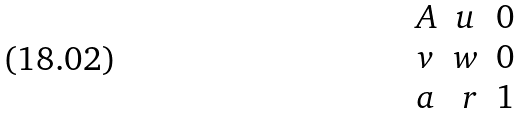Convert formula to latex. <formula><loc_0><loc_0><loc_500><loc_500>\begin{matrix} A & u & 0 \\ v & w & 0 \\ a & \ r & 1 \end{matrix}</formula> 